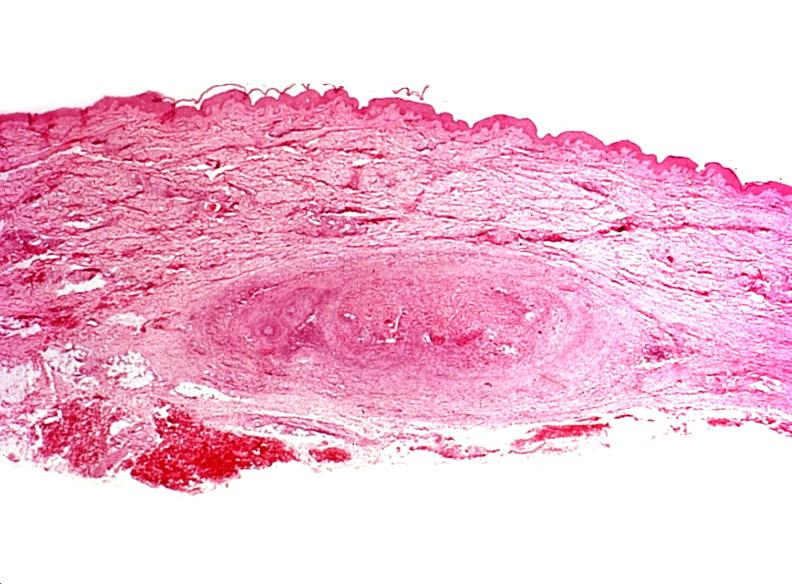what does this image show?
Answer the question using a single word or phrase. Migratory thrombophlebitis 